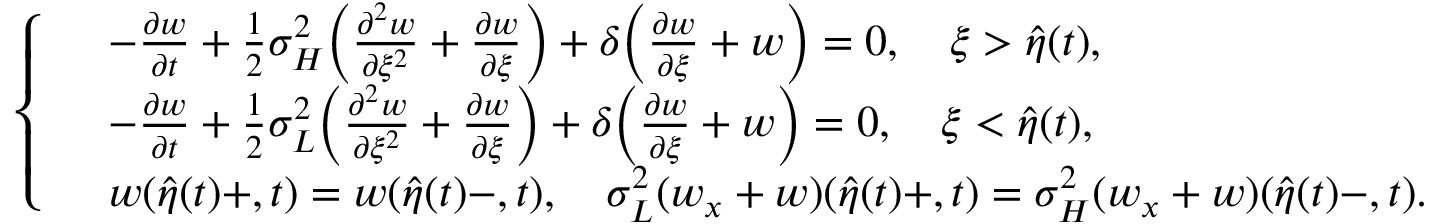<formula> <loc_0><loc_0><loc_500><loc_500>\left \{ \begin{array} { r l } & { - \frac { { \partial } w } { { \partial } t } + \frac { 1 } { 2 } { \sigma } _ { H } ^ { 2 } \left ( \frac { { \partial } ^ { 2 } w } { { \partial } \xi ^ { 2 } } + \frac { { \partial } w } { { \partial } \xi } \right ) + \delta \left ( \frac { { \partial } w } { { \partial } \xi } + w \right ) = 0 , \quad \xi > \hat { \eta } ( t ) , } \\ & { - \frac { { \partial } w } { { \partial } t } + \frac { 1 } { 2 } { \sigma } _ { L } ^ { 2 } \left ( \frac { { \partial } ^ { 2 } w } { { \partial } \xi ^ { 2 } } + \frac { { \partial } w } { { \partial } \xi } \right ) + \delta \left ( \frac { { \partial } w } { { \partial } \xi } + w \right ) = 0 , \quad \xi < \hat { \eta } ( t ) , } \\ & { w ( \hat { \eta } ( t ) + , t ) = w ( \hat { \eta } ( t ) - , t ) , \quad \sigma _ { L } ^ { 2 } ( w _ { x } + w ) ( \hat { \eta } ( t ) + , t ) = \sigma _ { H } ^ { 2 } ( w _ { x } + w ) ( \hat { \eta } ( t ) - , t ) . } \end{array}</formula> 